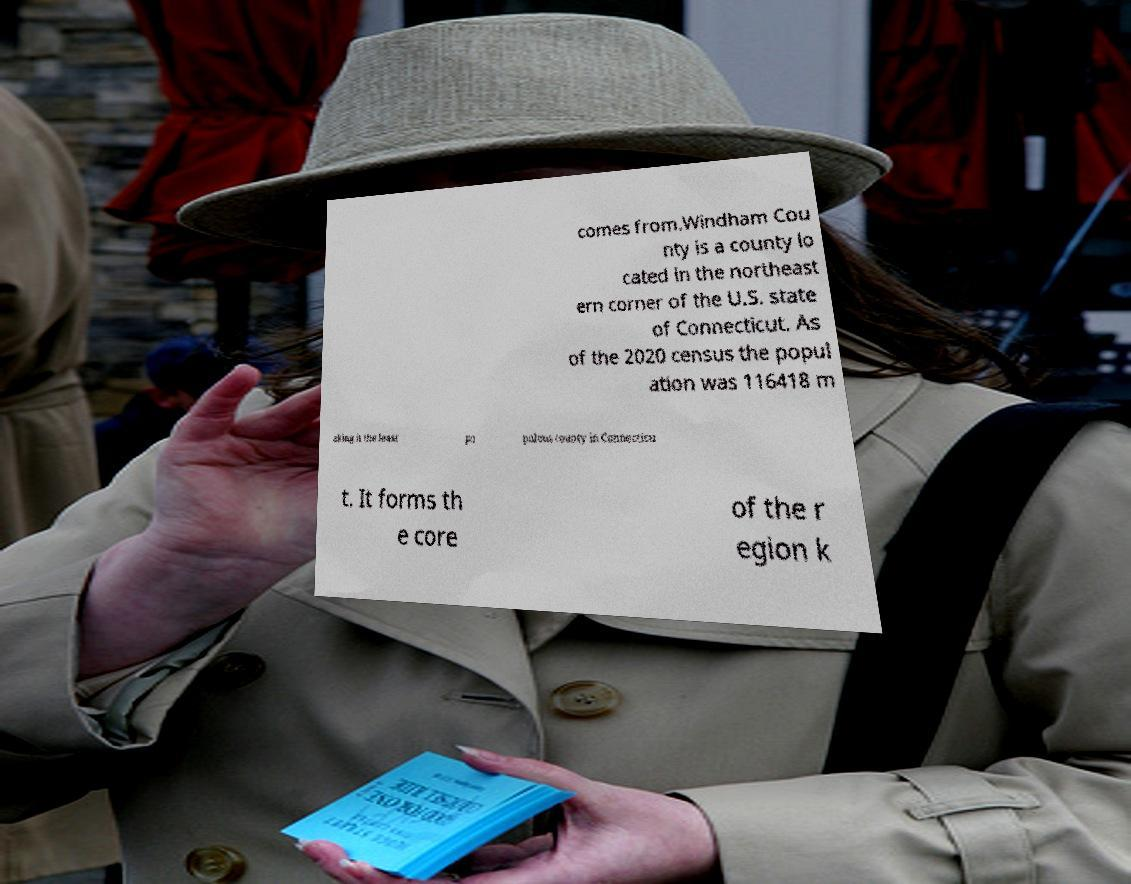Please identify and transcribe the text found in this image. comes from.Windham Cou nty is a county lo cated in the northeast ern corner of the U.S. state of Connecticut. As of the 2020 census the popul ation was 116418 m aking it the least po pulous county in Connecticu t. It forms th e core of the r egion k 